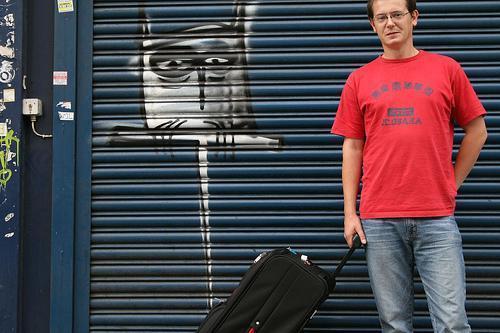How many people are there?
Give a very brief answer. 1. 